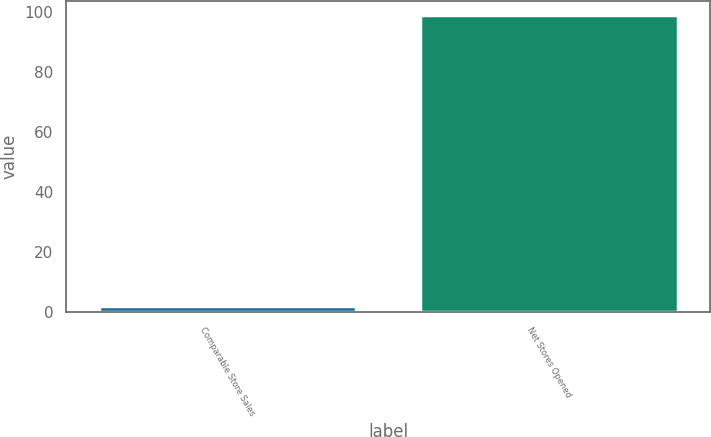Convert chart to OTSL. <chart><loc_0><loc_0><loc_500><loc_500><bar_chart><fcel>Comparable Store Sales<fcel>Net Stores Opened<nl><fcel>2.2<fcel>99<nl></chart> 